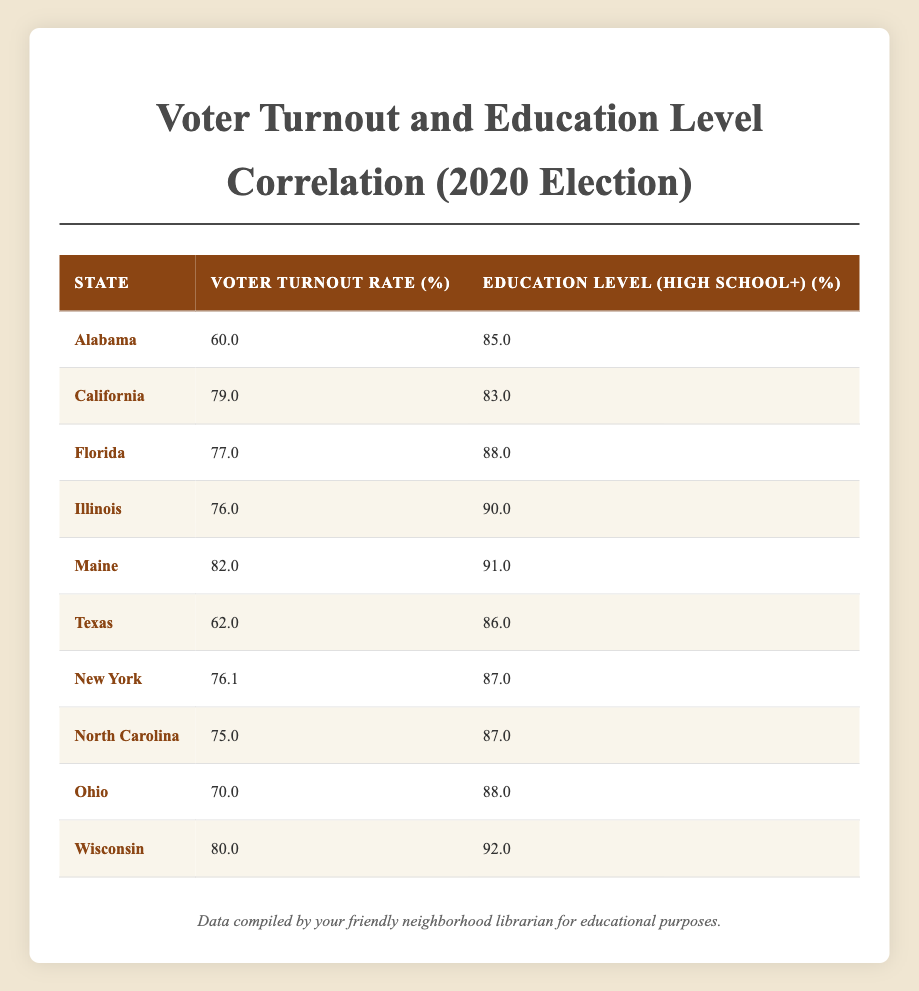What is the voter turnout rate in Alabama? In the table, locate the row for Alabama. The value in the "Voter Turnout Rate (%)" column for Alabama is 60.0.
Answer: 60.0 Which state has the highest education level percentage? Review the "Education Level (High School+) (%)" column to find the highest number. The maximum value is 92.0, which corresponds to Wisconsin.
Answer: Wisconsin Calculate the average voter turnout rate for all the states. Add up all the voter turnout rates: (60.0 + 79.0 + 77.0 + 76.0 + 82.0 + 62.0 + 76.1 + 75.0 + 70.0 + 80.0) = 79.1. Then, divide by the number of states (10): 79.1 / 10 = 79.1.
Answer: 79.1 Is the education level in Florida higher than in California? Compare the values in the "Education Level (High School+) (%)" column: Florida has 88.0 and California has 83.0. Since 88.0 > 83.0, the statement is true.
Answer: Yes Which states have a voter turnout rate above 75%? Check the "Voter Turnout Rate (%)" column for values greater than 75. The states meeting this criterion are California, Florida, Illinois, Maine, Wisconsin, and New York.
Answer: California, Florida, Illinois, Maine, Wisconsin, New York What is the difference in voter turnout rate between Texas and Maine? Locate the voter turnout rates for Texas (62.0) and Maine (82.0). The difference is calculated as 82.0 - 62.0 = 20.0.
Answer: 20.0 Does Illinois have a higher voter turnout rate than New York? Compare the values in the "Voter Turnout Rate (%)" column: Illinois has 76.0 and New York has 76.1. Since 76.0 is not greater than 76.1, the statement is false.
Answer: No If we average the education levels of the states with a turnout rate below 70%, what do we find? Identify states with turnout rates below 70%: Alabama (60.0) and Texas (62.0). Their education levels are 85.0 and 86.0, respectively. The average is calculated as (85.0 + 86.0) / 2 = 85.5.
Answer: 85.5 Which state has the lowest voter turnout rate? Review the "Voter Turnout Rate (%)" column. The lowest value is 60.0, which corresponds to Alabama.
Answer: Alabama 